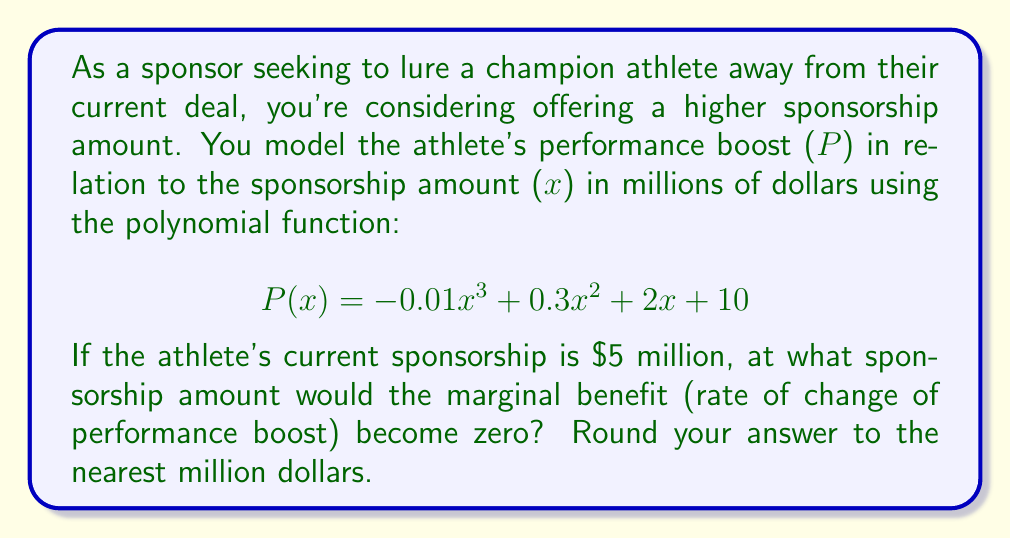Help me with this question. To solve this problem, we need to follow these steps:

1) The marginal benefit is represented by the first derivative of the performance function $P(x)$. Let's call this $P'(x)$.

2) Calculate $P'(x)$:
   $$P'(x) = -0.03x^2 + 0.6x + 2$$

3) To find where the marginal benefit becomes zero, we need to solve the equation:
   $$P'(x) = 0$$
   $$-0.03x^2 + 0.6x + 2 = 0$$

4) This is a quadratic equation. We can solve it using the quadratic formula:
   $$x = \frac{-b \pm \sqrt{b^2 - 4ac}}{2a}$$
   where $a = -0.03$, $b = 0.6$, and $c = 2$

5) Substituting these values:
   $$x = \frac{-0.6 \pm \sqrt{0.6^2 - 4(-0.03)(2)}}{2(-0.03)}$$
   $$= \frac{-0.6 \pm \sqrt{0.36 + 0.24}}{-0.06}$$
   $$= \frac{-0.6 \pm \sqrt{0.6}}{-0.06}$$
   $$= \frac{-0.6 \pm 0.7746}{-0.06}$$

6) This gives us two solutions:
   $$x_1 = \frac{-0.6 + 0.7746}{-0.06} \approx 2.91$$
   $$x_2 = \frac{-0.6 - 0.7746}{-0.06} \approx 22.91$$

7) Since the current sponsorship is $5 million, we're interested in the larger value, 22.91.

8) Rounding to the nearest million gives us 23 million dollars.
Answer: $23 million 